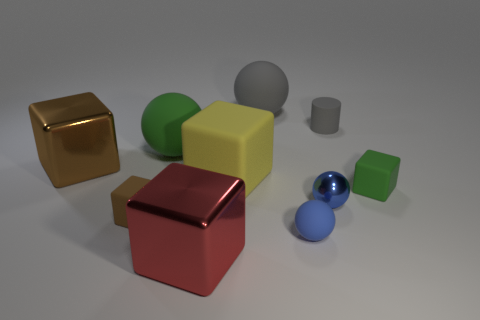Subtract all green blocks. How many blocks are left? 4 Subtract 2 cubes. How many cubes are left? 3 Subtract all brown blocks. How many blocks are left? 3 Add 6 gray objects. How many gray objects are left? 8 Add 3 big green matte objects. How many big green matte objects exist? 4 Subtract 0 purple cylinders. How many objects are left? 10 Subtract all cylinders. How many objects are left? 9 Subtract all gray blocks. Subtract all cyan balls. How many blocks are left? 5 Subtract all cyan blocks. How many brown spheres are left? 0 Subtract all tiny yellow shiny balls. Subtract all big matte cubes. How many objects are left? 9 